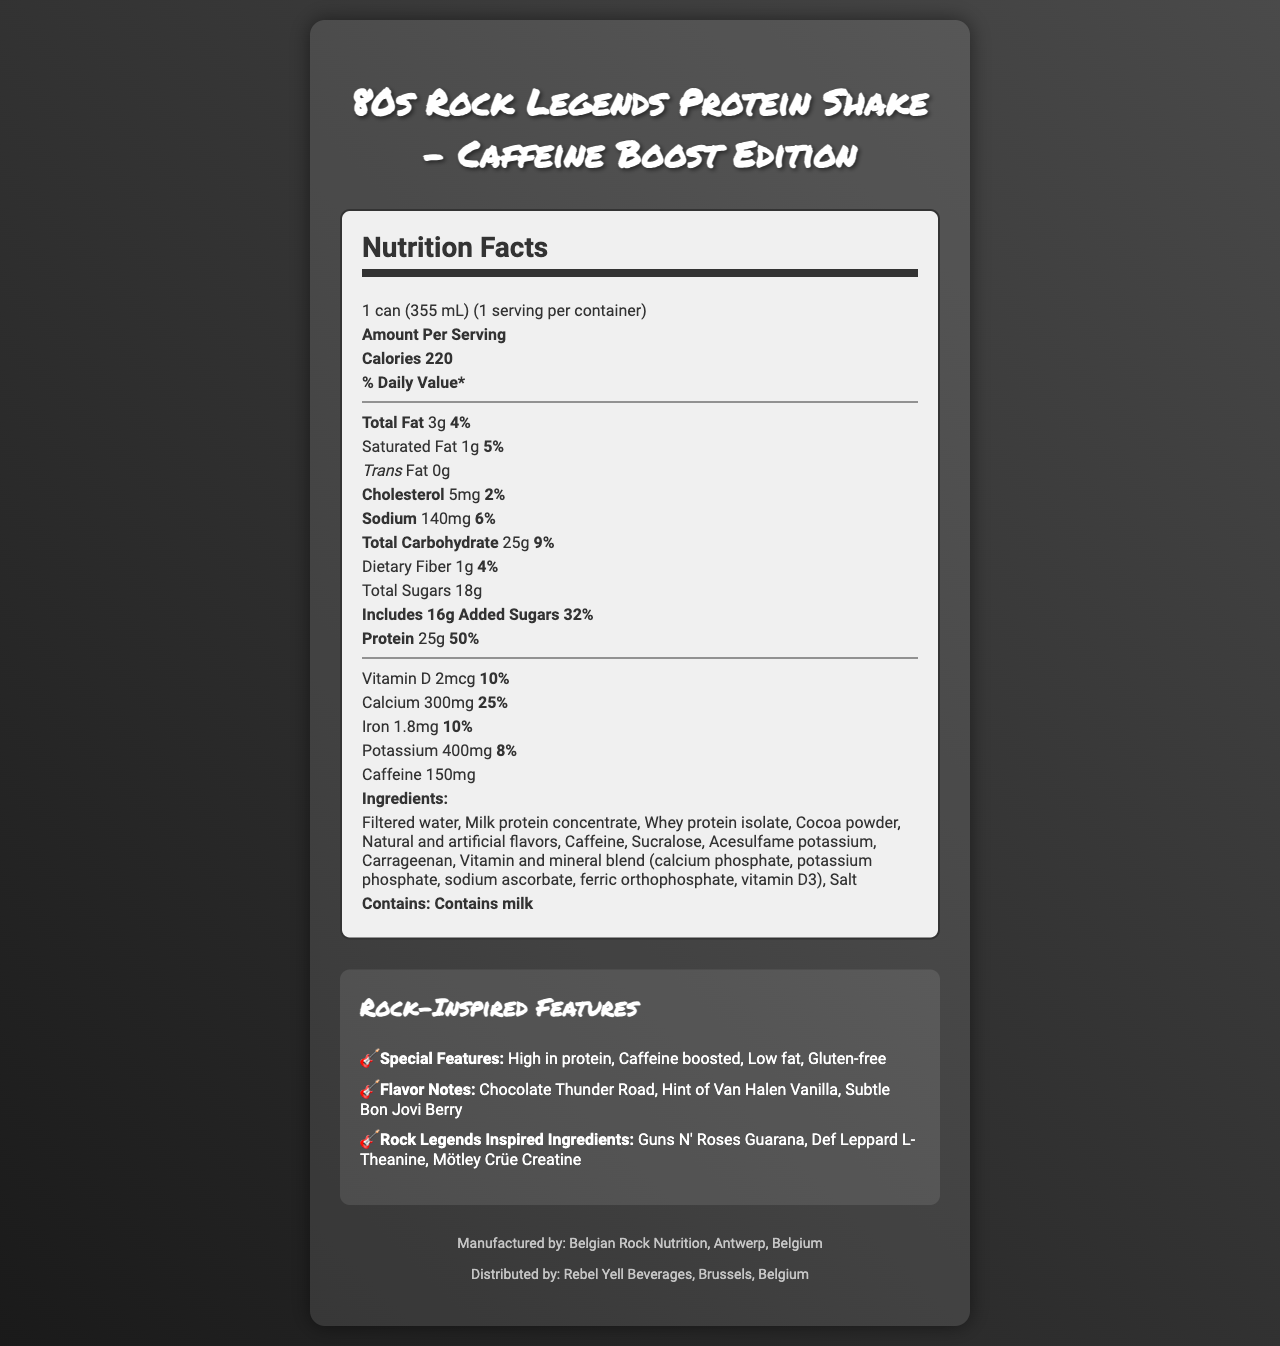what is the serving size? The document clearly states that the serving size is 1 can which equals 355 milliliters.
Answer: 1 can (355 mL) how many calories are in one serving? The nutrition label indicates that there are 220 calories per serving.
Answer: 220 what is the total fat content per serving? The label mentions that there are 3 grams of total fat per serving.
Answer: 3g what is the percentage of daily value for calcium? The document lists the daily value percentage for calcium as 25%.
Answer: 25% how much caffeine is in the product? The document explicitly states that the product contains 150mg of caffeine.
Answer: 150mg which company manufactures the 80s Rock Legends Protein Shake? A. Rebel Yell Beverages B. Belgian Rock Nutrition C. Antwerp Protein Labs D. Rock Legends Ltd. The footer of the document indicates that it is manufactured by Belgian Rock Nutrition.
Answer: B what are the special features of this product? A. High protein, caffeine boosted B. Low fat, gluten-free C. All of the above Under the "Rock-Inspired Features" section, the document lists "High in protein," "Caffeine boosted," "Low fat," and "Gluten-free" as the special features.
Answer: C is this product gluten-free? The special features section of the document states that the product is gluten-free.
Answer: Yes describe the main idea of the document. The document contains aggregated information about the nutrition, special features, flavor notes, and rock legends-inspired ingredients of the protein shake. It is visually appealing and themed to match the "80s Rock Legends" branding.
Answer: The document is a brightly designed nutrition facts label for the "80s Rock Legends Protein Shake - Caffeine Boost Edition." It provides detailed nutritional information, ingredients, allergen warnings, and special rock-inspired features, including high protein content, caffeine boost, and gluten-free attributes. It also includes creative flavor notes and ingredients inspired by rock legends, along with manufacturing and distribution details. who founded Belgian Rock Nutrition? The document does not provide any information about the founders of Belgian Rock Nutrition.
Answer: Cannot be determined What is the total sugar content per serving? The document indicates there are 18 grams of total sugars per serving.
Answer: 18g list two allergens contained in this product. The allergens section only states that the product contains milk.
Answer: milk how much protein does this shake provide in terms of daily value percentage? The protein amount section lists 25g protein which equates to 50% of the daily value.
Answer: 50% what is the iron content in this product? A. 1mg B. 1.8mg C. 5mg D. 10mg The nutrition facts section lists the iron content as 1.8mg.
Answer: B does the product include any creatine? The rock legends inspired ingredients section lists "Mötley Crüe Creatine" among the ingredients.
Answer: Yes how many grams of dietary fiber are included per serving? The nutrition facts label indicates there is 1 gram of dietary fiber per serving.
Answer: 1g 